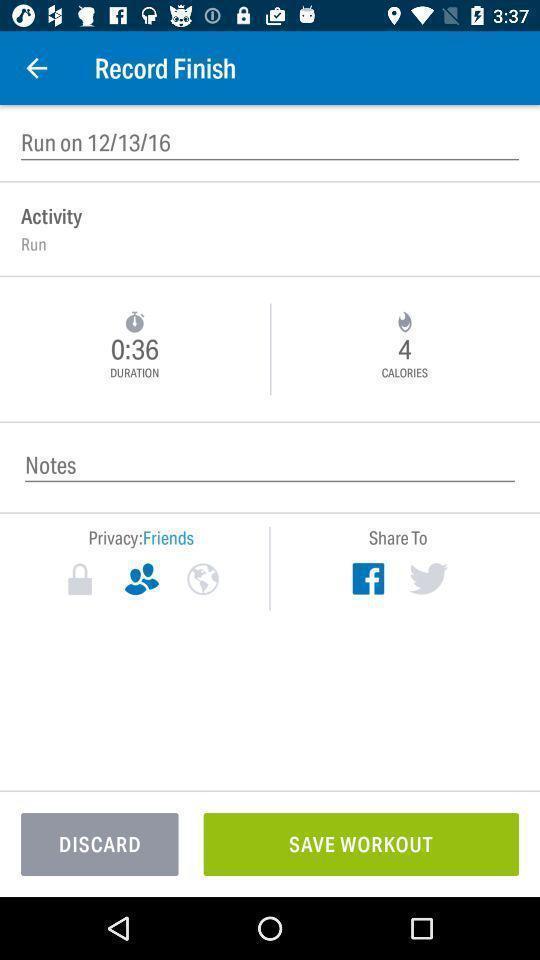Tell me about the visual elements in this screen capture. Page displaying the recording time of an activity. 